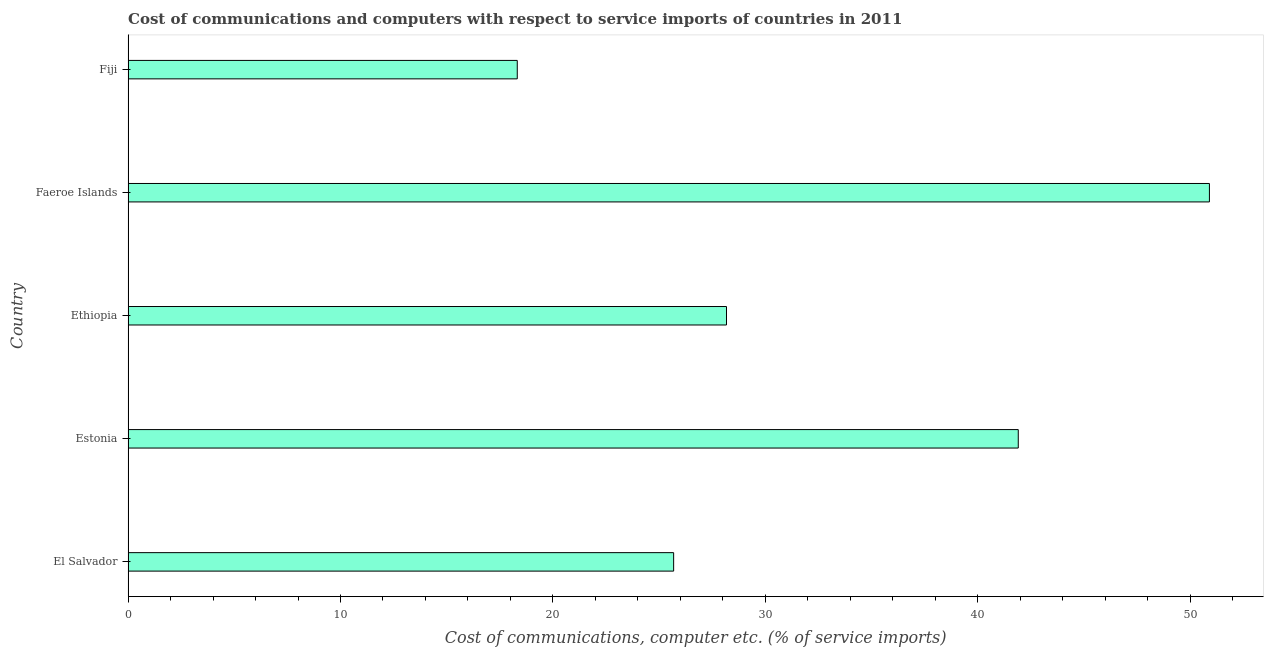Does the graph contain grids?
Offer a very short reply. No. What is the title of the graph?
Keep it short and to the point. Cost of communications and computers with respect to service imports of countries in 2011. What is the label or title of the X-axis?
Your response must be concise. Cost of communications, computer etc. (% of service imports). What is the label or title of the Y-axis?
Give a very brief answer. Country. What is the cost of communications and computer in Faeroe Islands?
Provide a short and direct response. 50.91. Across all countries, what is the maximum cost of communications and computer?
Offer a very short reply. 50.91. Across all countries, what is the minimum cost of communications and computer?
Your answer should be very brief. 18.32. In which country was the cost of communications and computer maximum?
Make the answer very short. Faeroe Islands. In which country was the cost of communications and computer minimum?
Give a very brief answer. Fiji. What is the sum of the cost of communications and computer?
Your answer should be compact. 165. What is the difference between the cost of communications and computer in Estonia and Faeroe Islands?
Keep it short and to the point. -9. What is the average cost of communications and computer per country?
Provide a short and direct response. 33. What is the median cost of communications and computer?
Your response must be concise. 28.17. What is the ratio of the cost of communications and computer in El Salvador to that in Faeroe Islands?
Make the answer very short. 0.51. Is the cost of communications and computer in El Salvador less than that in Fiji?
Provide a short and direct response. No. Is the difference between the cost of communications and computer in Faeroe Islands and Fiji greater than the difference between any two countries?
Offer a terse response. Yes. What is the difference between the highest and the second highest cost of communications and computer?
Offer a very short reply. 9. Is the sum of the cost of communications and computer in El Salvador and Fiji greater than the maximum cost of communications and computer across all countries?
Offer a very short reply. No. What is the difference between the highest and the lowest cost of communications and computer?
Provide a succinct answer. 32.59. Are all the bars in the graph horizontal?
Provide a short and direct response. Yes. How many countries are there in the graph?
Provide a succinct answer. 5. What is the difference between two consecutive major ticks on the X-axis?
Give a very brief answer. 10. Are the values on the major ticks of X-axis written in scientific E-notation?
Give a very brief answer. No. What is the Cost of communications, computer etc. (% of service imports) in El Salvador?
Your answer should be compact. 25.68. What is the Cost of communications, computer etc. (% of service imports) in Estonia?
Give a very brief answer. 41.91. What is the Cost of communications, computer etc. (% of service imports) of Ethiopia?
Offer a terse response. 28.17. What is the Cost of communications, computer etc. (% of service imports) in Faeroe Islands?
Ensure brevity in your answer.  50.91. What is the Cost of communications, computer etc. (% of service imports) in Fiji?
Keep it short and to the point. 18.32. What is the difference between the Cost of communications, computer etc. (% of service imports) in El Salvador and Estonia?
Ensure brevity in your answer.  -16.22. What is the difference between the Cost of communications, computer etc. (% of service imports) in El Salvador and Ethiopia?
Your response must be concise. -2.49. What is the difference between the Cost of communications, computer etc. (% of service imports) in El Salvador and Faeroe Islands?
Your answer should be very brief. -25.22. What is the difference between the Cost of communications, computer etc. (% of service imports) in El Salvador and Fiji?
Provide a short and direct response. 7.36. What is the difference between the Cost of communications, computer etc. (% of service imports) in Estonia and Ethiopia?
Keep it short and to the point. 13.74. What is the difference between the Cost of communications, computer etc. (% of service imports) in Estonia and Faeroe Islands?
Ensure brevity in your answer.  -9. What is the difference between the Cost of communications, computer etc. (% of service imports) in Estonia and Fiji?
Give a very brief answer. 23.59. What is the difference between the Cost of communications, computer etc. (% of service imports) in Ethiopia and Faeroe Islands?
Ensure brevity in your answer.  -22.74. What is the difference between the Cost of communications, computer etc. (% of service imports) in Ethiopia and Fiji?
Your response must be concise. 9.85. What is the difference between the Cost of communications, computer etc. (% of service imports) in Faeroe Islands and Fiji?
Your response must be concise. 32.59. What is the ratio of the Cost of communications, computer etc. (% of service imports) in El Salvador to that in Estonia?
Offer a terse response. 0.61. What is the ratio of the Cost of communications, computer etc. (% of service imports) in El Salvador to that in Ethiopia?
Provide a short and direct response. 0.91. What is the ratio of the Cost of communications, computer etc. (% of service imports) in El Salvador to that in Faeroe Islands?
Provide a succinct answer. 0.51. What is the ratio of the Cost of communications, computer etc. (% of service imports) in El Salvador to that in Fiji?
Your answer should be compact. 1.4. What is the ratio of the Cost of communications, computer etc. (% of service imports) in Estonia to that in Ethiopia?
Ensure brevity in your answer.  1.49. What is the ratio of the Cost of communications, computer etc. (% of service imports) in Estonia to that in Faeroe Islands?
Provide a succinct answer. 0.82. What is the ratio of the Cost of communications, computer etc. (% of service imports) in Estonia to that in Fiji?
Keep it short and to the point. 2.29. What is the ratio of the Cost of communications, computer etc. (% of service imports) in Ethiopia to that in Faeroe Islands?
Your answer should be compact. 0.55. What is the ratio of the Cost of communications, computer etc. (% of service imports) in Ethiopia to that in Fiji?
Your response must be concise. 1.54. What is the ratio of the Cost of communications, computer etc. (% of service imports) in Faeroe Islands to that in Fiji?
Your answer should be very brief. 2.78. 